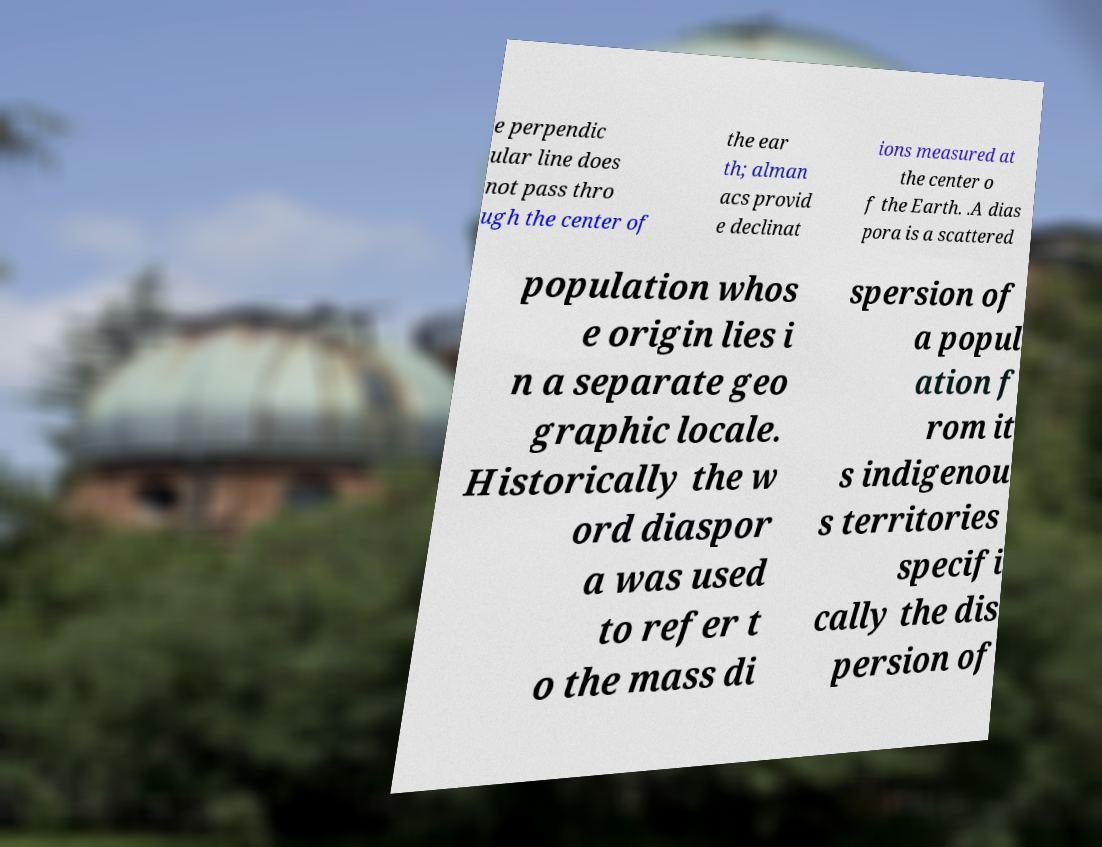Could you extract and type out the text from this image? e perpendic ular line does not pass thro ugh the center of the ear th; alman acs provid e declinat ions measured at the center o f the Earth. .A dias pora is a scattered population whos e origin lies i n a separate geo graphic locale. Historically the w ord diaspor a was used to refer t o the mass di spersion of a popul ation f rom it s indigenou s territories specifi cally the dis persion of 